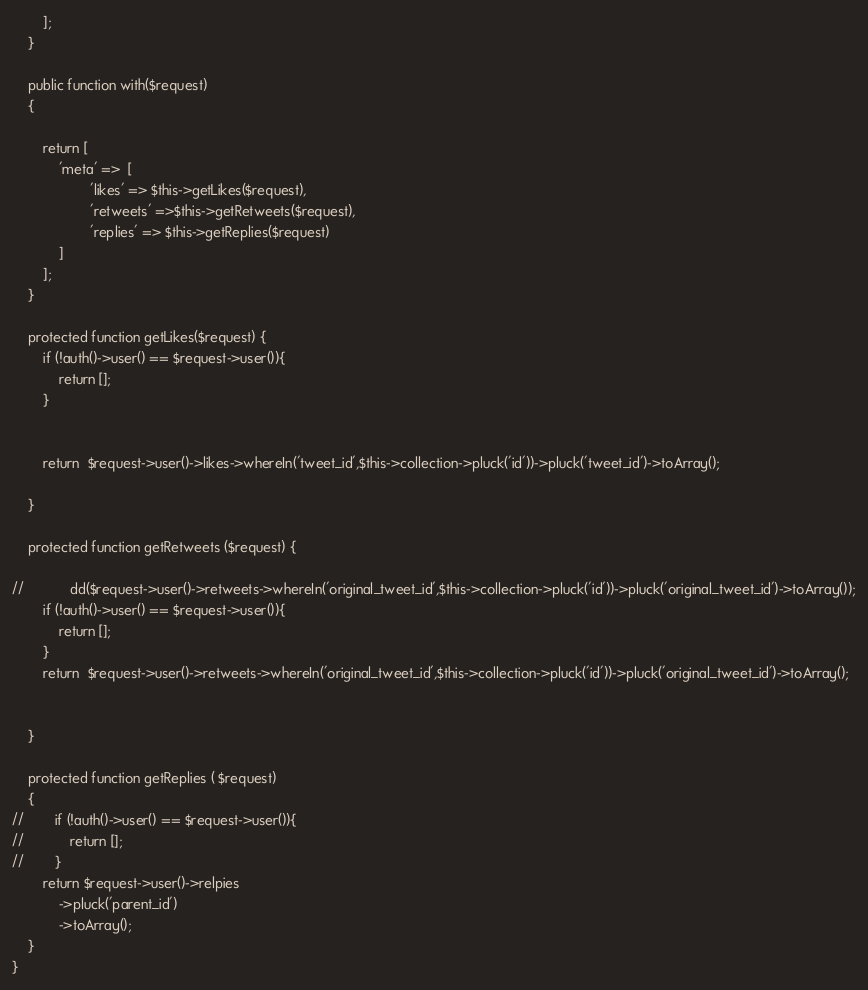<code> <loc_0><loc_0><loc_500><loc_500><_PHP_>        ];
    }

    public function with($request)
    {

        return [
            'meta' =>  [
                    'likes' => $this->getLikes($request),
                    'retweets' =>$this->getRetweets($request),
                    'replies' => $this->getReplies($request)
            ]
        ];
    }

    protected function getLikes($request) {
        if (!auth()->user() == $request->user()){
            return [];
        }


        return  $request->user()->likes->whereIn('tweet_id',$this->collection->pluck('id'))->pluck('tweet_id')->toArray();

    }

    protected function getRetweets ($request) {

//            dd($request->user()->retweets->whereIn('original_tweet_id',$this->collection->pluck('id'))->pluck('original_tweet_id')->toArray());
        if (!auth()->user() == $request->user()){
            return [];
        }
        return  $request->user()->retweets->whereIn('original_tweet_id',$this->collection->pluck('id'))->pluck('original_tweet_id')->toArray();


    }

    protected function getReplies ( $request)
    {
//        if (!auth()->user() == $request->user()){
//            return [];
//        }
        return $request->user()->relpies
            ->pluck('parent_id')
            ->toArray();
    }
}
</code> 